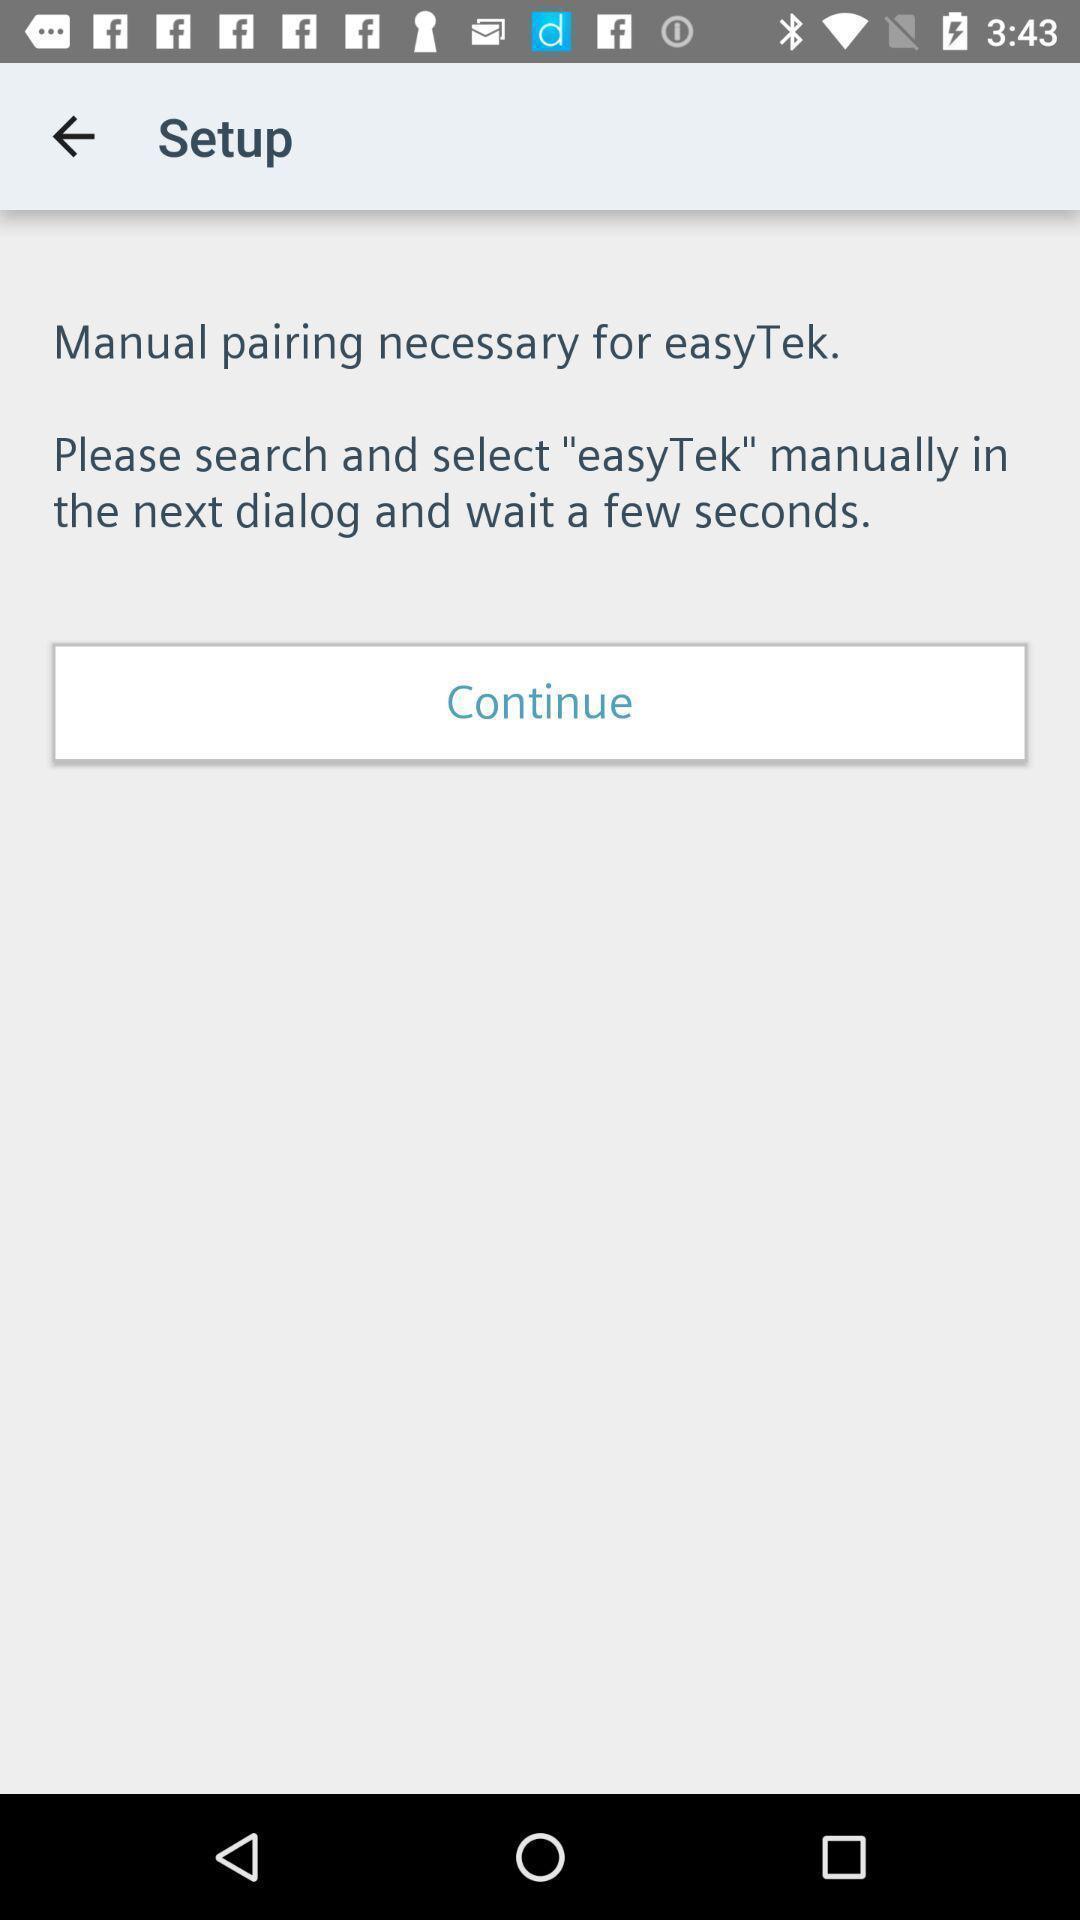Explain the elements present in this screenshot. Setup page of a easytek app. 